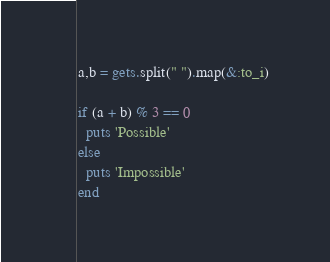Convert code to text. <code><loc_0><loc_0><loc_500><loc_500><_Ruby_>a,b = gets.split(" ").map(&:to_i)

if (a + b) % 3 == 0
  puts 'Possible'
else
  puts 'Impossible'
end</code> 